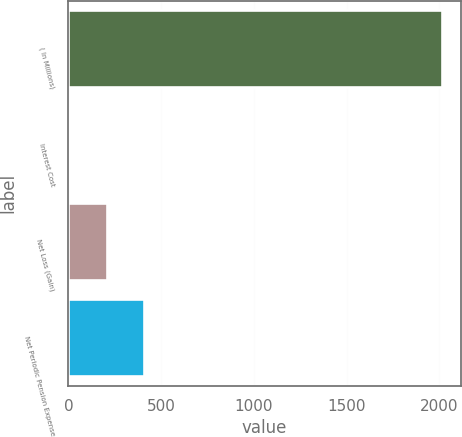Convert chart to OTSL. <chart><loc_0><loc_0><loc_500><loc_500><bar_chart><fcel>( In Millions)<fcel>Interest Cost<fcel>Net Loss (Gain)<fcel>Net Periodic Pension Expense<nl><fcel>2015<fcel>5<fcel>206<fcel>407<nl></chart> 